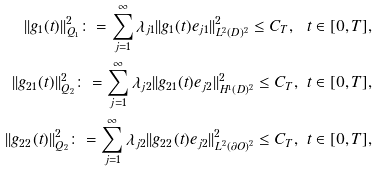Convert formula to latex. <formula><loc_0><loc_0><loc_500><loc_500>| | g _ { 1 } ( t ) | | ^ { 2 } _ { Q _ { 1 } } \colon = \sum _ { j = 1 } ^ { \infty } \lambda _ { j 1 } | | g _ { 1 } ( t ) e _ { j 1 } | | ^ { 2 } _ { L ^ { 2 } ( D ) ^ { 2 } } \leq C _ { T } , \ t \in [ 0 , T ] , \\ | | g _ { 2 1 } ( t ) | | ^ { 2 } _ { Q _ { 2 } } \colon = \sum _ { j = 1 } ^ { \infty } \lambda _ { j 2 } | | g _ { 2 1 } ( t ) e _ { j 2 } | | ^ { 2 } _ { H ^ { 1 } ( D ) ^ { 2 } } \leq C _ { T } , \ t \in [ 0 , T ] , \\ | | g _ { 2 2 } ( t ) | | ^ { 2 } _ { Q _ { 2 } } \colon = \sum _ { j = 1 } ^ { \infty } \lambda _ { j 2 } | | g _ { 2 2 } ( t ) e _ { j 2 } | | ^ { 2 } _ { L ^ { 2 } ( \partial O ) ^ { 2 } } \leq C _ { T } , \ t \in [ 0 , T ] , \\</formula> 